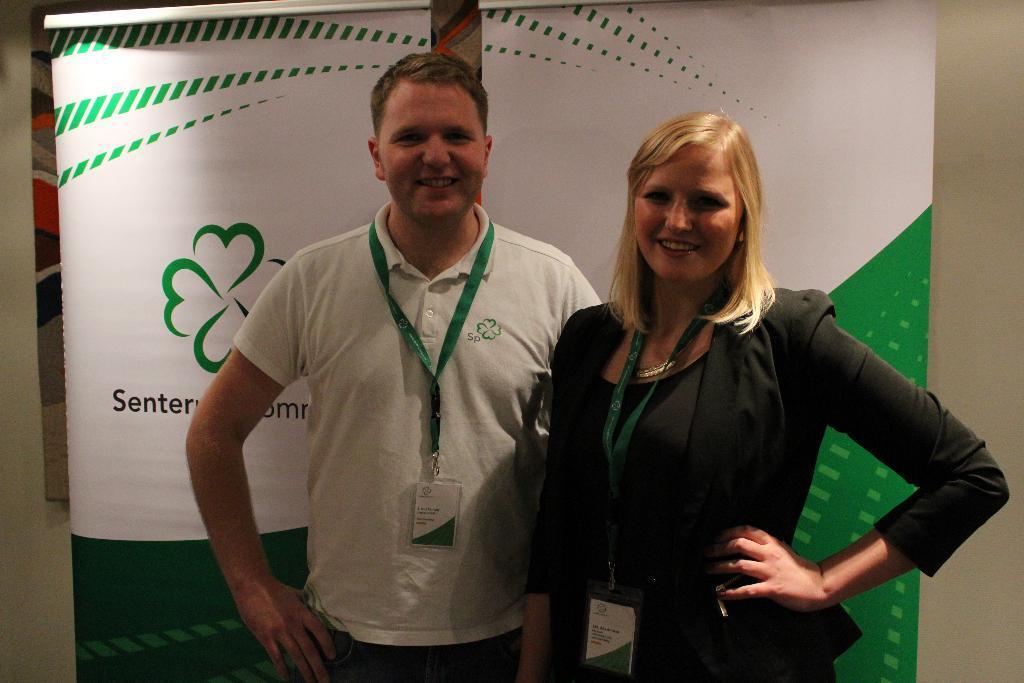How would you summarize this image in a sentence or two? In the image we can see a woman and a man standing. They are wearing clothes and identity card, they both are smiling. Behind them there are posters and a wall. 